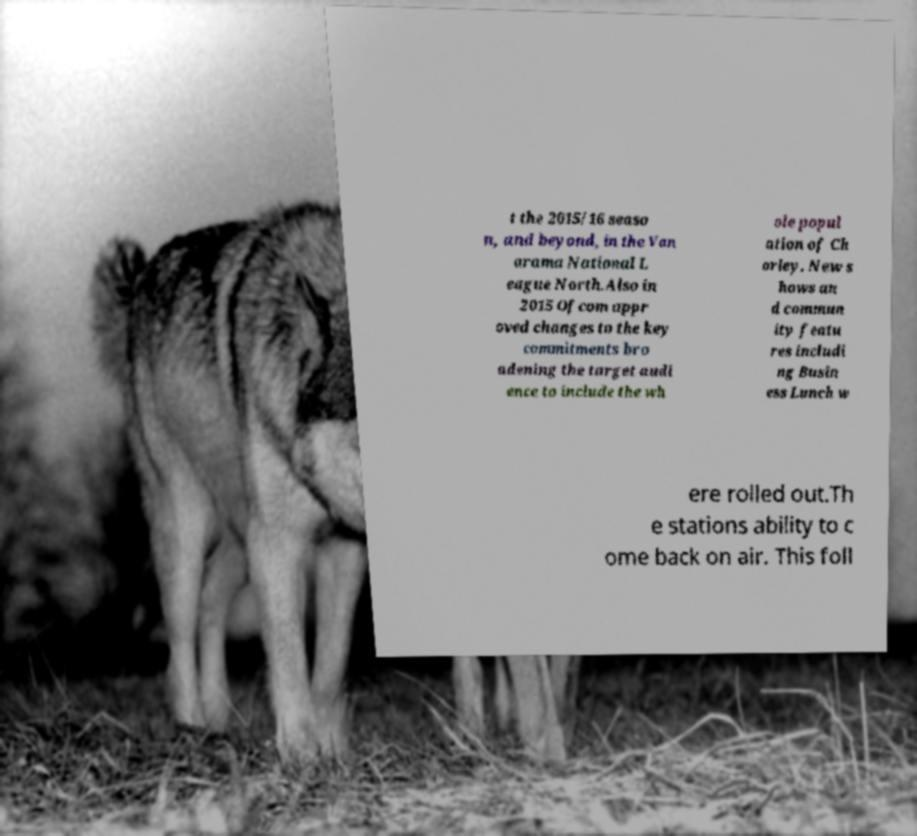Could you assist in decoding the text presented in this image and type it out clearly? t the 2015/16 seaso n, and beyond, in the Van arama National L eague North.Also in 2015 Ofcom appr oved changes to the key commitments bro adening the target audi ence to include the wh ole popul ation of Ch orley. New s hows an d commun ity featu res includi ng Busin ess Lunch w ere rolled out.Th e stations ability to c ome back on air. This foll 